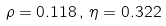<formula> <loc_0><loc_0><loc_500><loc_500>\rho = 0 . 1 1 8 \, , \, \eta = 0 . 3 2 2</formula> 